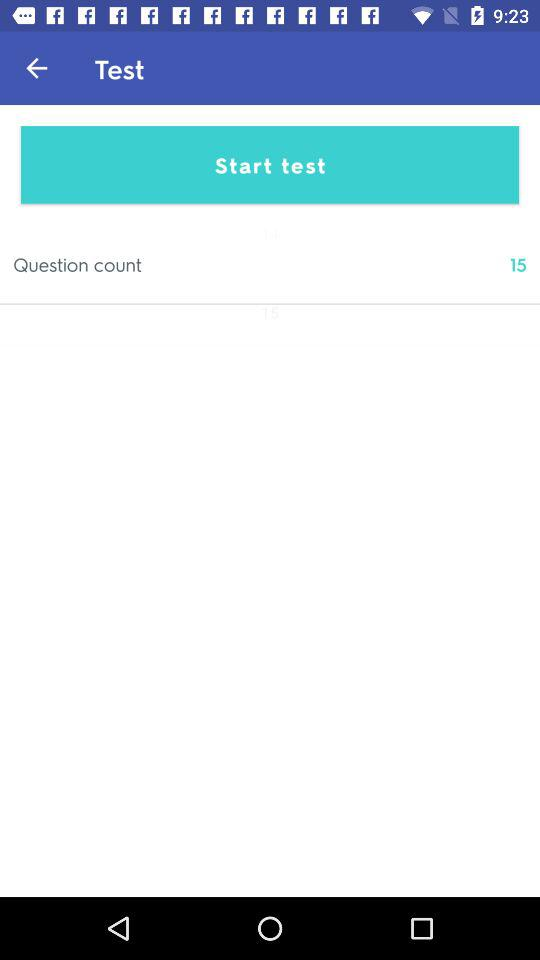How many topics does the test cover?
When the provided information is insufficient, respond with <no answer>. <no answer> 